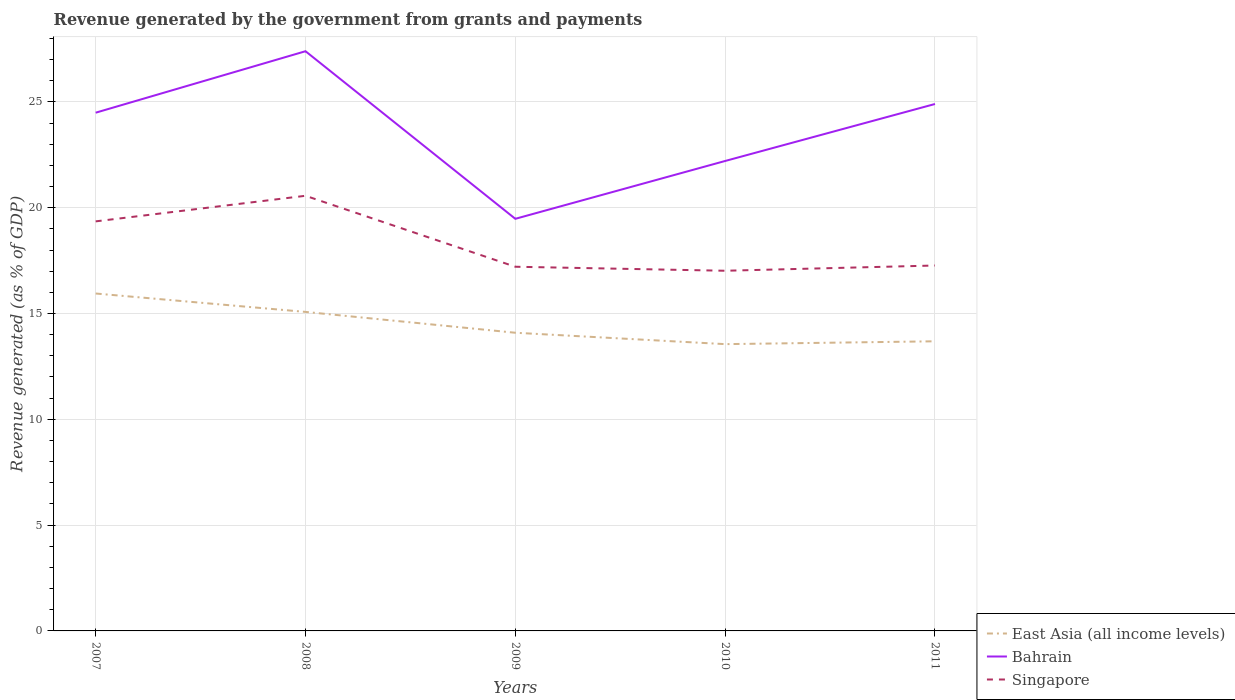Does the line corresponding to Bahrain intersect with the line corresponding to East Asia (all income levels)?
Offer a very short reply. No. Across all years, what is the maximum revenue generated by the government in East Asia (all income levels)?
Your answer should be compact. 13.55. What is the total revenue generated by the government in Bahrain in the graph?
Offer a very short reply. -2.73. What is the difference between the highest and the second highest revenue generated by the government in Bahrain?
Make the answer very short. 7.92. What is the difference between two consecutive major ticks on the Y-axis?
Make the answer very short. 5. Does the graph contain any zero values?
Give a very brief answer. No. Does the graph contain grids?
Offer a terse response. Yes. How are the legend labels stacked?
Your answer should be compact. Vertical. What is the title of the graph?
Provide a succinct answer. Revenue generated by the government from grants and payments. Does "Kosovo" appear as one of the legend labels in the graph?
Offer a very short reply. No. What is the label or title of the X-axis?
Your answer should be very brief. Years. What is the label or title of the Y-axis?
Offer a terse response. Revenue generated (as % of GDP). What is the Revenue generated (as % of GDP) in East Asia (all income levels) in 2007?
Your answer should be compact. 15.94. What is the Revenue generated (as % of GDP) in Bahrain in 2007?
Make the answer very short. 24.49. What is the Revenue generated (as % of GDP) in Singapore in 2007?
Give a very brief answer. 19.35. What is the Revenue generated (as % of GDP) of East Asia (all income levels) in 2008?
Make the answer very short. 15.07. What is the Revenue generated (as % of GDP) of Bahrain in 2008?
Ensure brevity in your answer.  27.39. What is the Revenue generated (as % of GDP) in Singapore in 2008?
Ensure brevity in your answer.  20.56. What is the Revenue generated (as % of GDP) of East Asia (all income levels) in 2009?
Give a very brief answer. 14.09. What is the Revenue generated (as % of GDP) of Bahrain in 2009?
Make the answer very short. 19.47. What is the Revenue generated (as % of GDP) in Singapore in 2009?
Your answer should be compact. 17.21. What is the Revenue generated (as % of GDP) in East Asia (all income levels) in 2010?
Provide a succinct answer. 13.55. What is the Revenue generated (as % of GDP) in Bahrain in 2010?
Your response must be concise. 22.21. What is the Revenue generated (as % of GDP) of Singapore in 2010?
Your answer should be very brief. 17.02. What is the Revenue generated (as % of GDP) of East Asia (all income levels) in 2011?
Make the answer very short. 13.69. What is the Revenue generated (as % of GDP) of Bahrain in 2011?
Provide a short and direct response. 24.9. What is the Revenue generated (as % of GDP) of Singapore in 2011?
Your response must be concise. 17.27. Across all years, what is the maximum Revenue generated (as % of GDP) of East Asia (all income levels)?
Offer a very short reply. 15.94. Across all years, what is the maximum Revenue generated (as % of GDP) of Bahrain?
Give a very brief answer. 27.39. Across all years, what is the maximum Revenue generated (as % of GDP) in Singapore?
Provide a short and direct response. 20.56. Across all years, what is the minimum Revenue generated (as % of GDP) of East Asia (all income levels)?
Ensure brevity in your answer.  13.55. Across all years, what is the minimum Revenue generated (as % of GDP) of Bahrain?
Ensure brevity in your answer.  19.47. Across all years, what is the minimum Revenue generated (as % of GDP) in Singapore?
Offer a very short reply. 17.02. What is the total Revenue generated (as % of GDP) in East Asia (all income levels) in the graph?
Ensure brevity in your answer.  72.35. What is the total Revenue generated (as % of GDP) in Bahrain in the graph?
Offer a very short reply. 118.46. What is the total Revenue generated (as % of GDP) in Singapore in the graph?
Give a very brief answer. 91.41. What is the difference between the Revenue generated (as % of GDP) of East Asia (all income levels) in 2007 and that in 2008?
Offer a very short reply. 0.87. What is the difference between the Revenue generated (as % of GDP) in Bahrain in 2007 and that in 2008?
Ensure brevity in your answer.  -2.91. What is the difference between the Revenue generated (as % of GDP) of Singapore in 2007 and that in 2008?
Provide a succinct answer. -1.21. What is the difference between the Revenue generated (as % of GDP) of East Asia (all income levels) in 2007 and that in 2009?
Offer a very short reply. 1.85. What is the difference between the Revenue generated (as % of GDP) of Bahrain in 2007 and that in 2009?
Ensure brevity in your answer.  5.01. What is the difference between the Revenue generated (as % of GDP) of Singapore in 2007 and that in 2009?
Your answer should be compact. 2.14. What is the difference between the Revenue generated (as % of GDP) of East Asia (all income levels) in 2007 and that in 2010?
Give a very brief answer. 2.39. What is the difference between the Revenue generated (as % of GDP) of Bahrain in 2007 and that in 2010?
Keep it short and to the point. 2.28. What is the difference between the Revenue generated (as % of GDP) in Singapore in 2007 and that in 2010?
Your answer should be compact. 2.33. What is the difference between the Revenue generated (as % of GDP) in East Asia (all income levels) in 2007 and that in 2011?
Keep it short and to the point. 2.26. What is the difference between the Revenue generated (as % of GDP) of Bahrain in 2007 and that in 2011?
Give a very brief answer. -0.41. What is the difference between the Revenue generated (as % of GDP) of Singapore in 2007 and that in 2011?
Make the answer very short. 2.09. What is the difference between the Revenue generated (as % of GDP) in East Asia (all income levels) in 2008 and that in 2009?
Keep it short and to the point. 0.99. What is the difference between the Revenue generated (as % of GDP) in Bahrain in 2008 and that in 2009?
Ensure brevity in your answer.  7.92. What is the difference between the Revenue generated (as % of GDP) of Singapore in 2008 and that in 2009?
Offer a very short reply. 3.35. What is the difference between the Revenue generated (as % of GDP) in East Asia (all income levels) in 2008 and that in 2010?
Make the answer very short. 1.52. What is the difference between the Revenue generated (as % of GDP) in Bahrain in 2008 and that in 2010?
Your answer should be very brief. 5.19. What is the difference between the Revenue generated (as % of GDP) in Singapore in 2008 and that in 2010?
Provide a succinct answer. 3.54. What is the difference between the Revenue generated (as % of GDP) in East Asia (all income levels) in 2008 and that in 2011?
Your response must be concise. 1.39. What is the difference between the Revenue generated (as % of GDP) of Bahrain in 2008 and that in 2011?
Provide a succinct answer. 2.49. What is the difference between the Revenue generated (as % of GDP) in Singapore in 2008 and that in 2011?
Offer a very short reply. 3.29. What is the difference between the Revenue generated (as % of GDP) of East Asia (all income levels) in 2009 and that in 2010?
Keep it short and to the point. 0.54. What is the difference between the Revenue generated (as % of GDP) in Bahrain in 2009 and that in 2010?
Keep it short and to the point. -2.73. What is the difference between the Revenue generated (as % of GDP) in Singapore in 2009 and that in 2010?
Keep it short and to the point. 0.19. What is the difference between the Revenue generated (as % of GDP) of East Asia (all income levels) in 2009 and that in 2011?
Your answer should be very brief. 0.4. What is the difference between the Revenue generated (as % of GDP) of Bahrain in 2009 and that in 2011?
Provide a short and direct response. -5.43. What is the difference between the Revenue generated (as % of GDP) in Singapore in 2009 and that in 2011?
Ensure brevity in your answer.  -0.06. What is the difference between the Revenue generated (as % of GDP) in East Asia (all income levels) in 2010 and that in 2011?
Keep it short and to the point. -0.13. What is the difference between the Revenue generated (as % of GDP) in Bahrain in 2010 and that in 2011?
Give a very brief answer. -2.69. What is the difference between the Revenue generated (as % of GDP) in Singapore in 2010 and that in 2011?
Provide a succinct answer. -0.25. What is the difference between the Revenue generated (as % of GDP) in East Asia (all income levels) in 2007 and the Revenue generated (as % of GDP) in Bahrain in 2008?
Your response must be concise. -11.45. What is the difference between the Revenue generated (as % of GDP) of East Asia (all income levels) in 2007 and the Revenue generated (as % of GDP) of Singapore in 2008?
Provide a short and direct response. -4.62. What is the difference between the Revenue generated (as % of GDP) in Bahrain in 2007 and the Revenue generated (as % of GDP) in Singapore in 2008?
Make the answer very short. 3.93. What is the difference between the Revenue generated (as % of GDP) in East Asia (all income levels) in 2007 and the Revenue generated (as % of GDP) in Bahrain in 2009?
Offer a terse response. -3.53. What is the difference between the Revenue generated (as % of GDP) in East Asia (all income levels) in 2007 and the Revenue generated (as % of GDP) in Singapore in 2009?
Your answer should be very brief. -1.27. What is the difference between the Revenue generated (as % of GDP) in Bahrain in 2007 and the Revenue generated (as % of GDP) in Singapore in 2009?
Provide a short and direct response. 7.28. What is the difference between the Revenue generated (as % of GDP) of East Asia (all income levels) in 2007 and the Revenue generated (as % of GDP) of Bahrain in 2010?
Provide a short and direct response. -6.26. What is the difference between the Revenue generated (as % of GDP) of East Asia (all income levels) in 2007 and the Revenue generated (as % of GDP) of Singapore in 2010?
Provide a succinct answer. -1.08. What is the difference between the Revenue generated (as % of GDP) in Bahrain in 2007 and the Revenue generated (as % of GDP) in Singapore in 2010?
Make the answer very short. 7.47. What is the difference between the Revenue generated (as % of GDP) in East Asia (all income levels) in 2007 and the Revenue generated (as % of GDP) in Bahrain in 2011?
Your answer should be compact. -8.96. What is the difference between the Revenue generated (as % of GDP) of East Asia (all income levels) in 2007 and the Revenue generated (as % of GDP) of Singapore in 2011?
Offer a very short reply. -1.32. What is the difference between the Revenue generated (as % of GDP) in Bahrain in 2007 and the Revenue generated (as % of GDP) in Singapore in 2011?
Give a very brief answer. 7.22. What is the difference between the Revenue generated (as % of GDP) of East Asia (all income levels) in 2008 and the Revenue generated (as % of GDP) of Bahrain in 2009?
Your answer should be compact. -4.4. What is the difference between the Revenue generated (as % of GDP) in East Asia (all income levels) in 2008 and the Revenue generated (as % of GDP) in Singapore in 2009?
Your answer should be very brief. -2.13. What is the difference between the Revenue generated (as % of GDP) in Bahrain in 2008 and the Revenue generated (as % of GDP) in Singapore in 2009?
Offer a terse response. 10.18. What is the difference between the Revenue generated (as % of GDP) of East Asia (all income levels) in 2008 and the Revenue generated (as % of GDP) of Bahrain in 2010?
Offer a very short reply. -7.13. What is the difference between the Revenue generated (as % of GDP) in East Asia (all income levels) in 2008 and the Revenue generated (as % of GDP) in Singapore in 2010?
Your response must be concise. -1.94. What is the difference between the Revenue generated (as % of GDP) in Bahrain in 2008 and the Revenue generated (as % of GDP) in Singapore in 2010?
Ensure brevity in your answer.  10.37. What is the difference between the Revenue generated (as % of GDP) of East Asia (all income levels) in 2008 and the Revenue generated (as % of GDP) of Bahrain in 2011?
Your answer should be very brief. -9.82. What is the difference between the Revenue generated (as % of GDP) in East Asia (all income levels) in 2008 and the Revenue generated (as % of GDP) in Singapore in 2011?
Offer a terse response. -2.19. What is the difference between the Revenue generated (as % of GDP) of Bahrain in 2008 and the Revenue generated (as % of GDP) of Singapore in 2011?
Keep it short and to the point. 10.13. What is the difference between the Revenue generated (as % of GDP) in East Asia (all income levels) in 2009 and the Revenue generated (as % of GDP) in Bahrain in 2010?
Ensure brevity in your answer.  -8.12. What is the difference between the Revenue generated (as % of GDP) in East Asia (all income levels) in 2009 and the Revenue generated (as % of GDP) in Singapore in 2010?
Offer a very short reply. -2.93. What is the difference between the Revenue generated (as % of GDP) in Bahrain in 2009 and the Revenue generated (as % of GDP) in Singapore in 2010?
Keep it short and to the point. 2.45. What is the difference between the Revenue generated (as % of GDP) in East Asia (all income levels) in 2009 and the Revenue generated (as % of GDP) in Bahrain in 2011?
Provide a succinct answer. -10.81. What is the difference between the Revenue generated (as % of GDP) in East Asia (all income levels) in 2009 and the Revenue generated (as % of GDP) in Singapore in 2011?
Provide a succinct answer. -3.18. What is the difference between the Revenue generated (as % of GDP) in Bahrain in 2009 and the Revenue generated (as % of GDP) in Singapore in 2011?
Your answer should be very brief. 2.21. What is the difference between the Revenue generated (as % of GDP) of East Asia (all income levels) in 2010 and the Revenue generated (as % of GDP) of Bahrain in 2011?
Provide a succinct answer. -11.35. What is the difference between the Revenue generated (as % of GDP) of East Asia (all income levels) in 2010 and the Revenue generated (as % of GDP) of Singapore in 2011?
Ensure brevity in your answer.  -3.72. What is the difference between the Revenue generated (as % of GDP) in Bahrain in 2010 and the Revenue generated (as % of GDP) in Singapore in 2011?
Provide a succinct answer. 4.94. What is the average Revenue generated (as % of GDP) in East Asia (all income levels) per year?
Provide a short and direct response. 14.47. What is the average Revenue generated (as % of GDP) in Bahrain per year?
Your answer should be compact. 23.69. What is the average Revenue generated (as % of GDP) of Singapore per year?
Your response must be concise. 18.28. In the year 2007, what is the difference between the Revenue generated (as % of GDP) in East Asia (all income levels) and Revenue generated (as % of GDP) in Bahrain?
Your response must be concise. -8.54. In the year 2007, what is the difference between the Revenue generated (as % of GDP) in East Asia (all income levels) and Revenue generated (as % of GDP) in Singapore?
Offer a terse response. -3.41. In the year 2007, what is the difference between the Revenue generated (as % of GDP) of Bahrain and Revenue generated (as % of GDP) of Singapore?
Give a very brief answer. 5.13. In the year 2008, what is the difference between the Revenue generated (as % of GDP) of East Asia (all income levels) and Revenue generated (as % of GDP) of Bahrain?
Offer a terse response. -12.32. In the year 2008, what is the difference between the Revenue generated (as % of GDP) of East Asia (all income levels) and Revenue generated (as % of GDP) of Singapore?
Provide a short and direct response. -5.49. In the year 2008, what is the difference between the Revenue generated (as % of GDP) of Bahrain and Revenue generated (as % of GDP) of Singapore?
Your answer should be compact. 6.83. In the year 2009, what is the difference between the Revenue generated (as % of GDP) in East Asia (all income levels) and Revenue generated (as % of GDP) in Bahrain?
Keep it short and to the point. -5.38. In the year 2009, what is the difference between the Revenue generated (as % of GDP) of East Asia (all income levels) and Revenue generated (as % of GDP) of Singapore?
Provide a succinct answer. -3.12. In the year 2009, what is the difference between the Revenue generated (as % of GDP) of Bahrain and Revenue generated (as % of GDP) of Singapore?
Ensure brevity in your answer.  2.26. In the year 2010, what is the difference between the Revenue generated (as % of GDP) of East Asia (all income levels) and Revenue generated (as % of GDP) of Bahrain?
Provide a succinct answer. -8.66. In the year 2010, what is the difference between the Revenue generated (as % of GDP) of East Asia (all income levels) and Revenue generated (as % of GDP) of Singapore?
Your answer should be very brief. -3.47. In the year 2010, what is the difference between the Revenue generated (as % of GDP) of Bahrain and Revenue generated (as % of GDP) of Singapore?
Your answer should be very brief. 5.19. In the year 2011, what is the difference between the Revenue generated (as % of GDP) of East Asia (all income levels) and Revenue generated (as % of GDP) of Bahrain?
Offer a terse response. -11.21. In the year 2011, what is the difference between the Revenue generated (as % of GDP) in East Asia (all income levels) and Revenue generated (as % of GDP) in Singapore?
Your response must be concise. -3.58. In the year 2011, what is the difference between the Revenue generated (as % of GDP) in Bahrain and Revenue generated (as % of GDP) in Singapore?
Make the answer very short. 7.63. What is the ratio of the Revenue generated (as % of GDP) in East Asia (all income levels) in 2007 to that in 2008?
Your answer should be very brief. 1.06. What is the ratio of the Revenue generated (as % of GDP) of Bahrain in 2007 to that in 2008?
Your answer should be compact. 0.89. What is the ratio of the Revenue generated (as % of GDP) of Singapore in 2007 to that in 2008?
Offer a very short reply. 0.94. What is the ratio of the Revenue generated (as % of GDP) of East Asia (all income levels) in 2007 to that in 2009?
Provide a succinct answer. 1.13. What is the ratio of the Revenue generated (as % of GDP) of Bahrain in 2007 to that in 2009?
Provide a short and direct response. 1.26. What is the ratio of the Revenue generated (as % of GDP) in Singapore in 2007 to that in 2009?
Provide a short and direct response. 1.12. What is the ratio of the Revenue generated (as % of GDP) of East Asia (all income levels) in 2007 to that in 2010?
Give a very brief answer. 1.18. What is the ratio of the Revenue generated (as % of GDP) in Bahrain in 2007 to that in 2010?
Make the answer very short. 1.1. What is the ratio of the Revenue generated (as % of GDP) of Singapore in 2007 to that in 2010?
Offer a terse response. 1.14. What is the ratio of the Revenue generated (as % of GDP) of East Asia (all income levels) in 2007 to that in 2011?
Keep it short and to the point. 1.17. What is the ratio of the Revenue generated (as % of GDP) in Bahrain in 2007 to that in 2011?
Provide a short and direct response. 0.98. What is the ratio of the Revenue generated (as % of GDP) of Singapore in 2007 to that in 2011?
Make the answer very short. 1.12. What is the ratio of the Revenue generated (as % of GDP) of East Asia (all income levels) in 2008 to that in 2009?
Keep it short and to the point. 1.07. What is the ratio of the Revenue generated (as % of GDP) in Bahrain in 2008 to that in 2009?
Provide a succinct answer. 1.41. What is the ratio of the Revenue generated (as % of GDP) in Singapore in 2008 to that in 2009?
Keep it short and to the point. 1.19. What is the ratio of the Revenue generated (as % of GDP) of East Asia (all income levels) in 2008 to that in 2010?
Offer a very short reply. 1.11. What is the ratio of the Revenue generated (as % of GDP) in Bahrain in 2008 to that in 2010?
Give a very brief answer. 1.23. What is the ratio of the Revenue generated (as % of GDP) in Singapore in 2008 to that in 2010?
Provide a short and direct response. 1.21. What is the ratio of the Revenue generated (as % of GDP) of East Asia (all income levels) in 2008 to that in 2011?
Your response must be concise. 1.1. What is the ratio of the Revenue generated (as % of GDP) in Bahrain in 2008 to that in 2011?
Ensure brevity in your answer.  1.1. What is the ratio of the Revenue generated (as % of GDP) in Singapore in 2008 to that in 2011?
Make the answer very short. 1.19. What is the ratio of the Revenue generated (as % of GDP) of East Asia (all income levels) in 2009 to that in 2010?
Provide a short and direct response. 1.04. What is the ratio of the Revenue generated (as % of GDP) of Bahrain in 2009 to that in 2010?
Offer a very short reply. 0.88. What is the ratio of the Revenue generated (as % of GDP) in Singapore in 2009 to that in 2010?
Your answer should be compact. 1.01. What is the ratio of the Revenue generated (as % of GDP) of East Asia (all income levels) in 2009 to that in 2011?
Offer a terse response. 1.03. What is the ratio of the Revenue generated (as % of GDP) of Bahrain in 2009 to that in 2011?
Give a very brief answer. 0.78. What is the ratio of the Revenue generated (as % of GDP) in East Asia (all income levels) in 2010 to that in 2011?
Make the answer very short. 0.99. What is the ratio of the Revenue generated (as % of GDP) of Bahrain in 2010 to that in 2011?
Your response must be concise. 0.89. What is the ratio of the Revenue generated (as % of GDP) of Singapore in 2010 to that in 2011?
Provide a short and direct response. 0.99. What is the difference between the highest and the second highest Revenue generated (as % of GDP) in East Asia (all income levels)?
Your answer should be compact. 0.87. What is the difference between the highest and the second highest Revenue generated (as % of GDP) of Bahrain?
Provide a short and direct response. 2.49. What is the difference between the highest and the second highest Revenue generated (as % of GDP) in Singapore?
Your answer should be compact. 1.21. What is the difference between the highest and the lowest Revenue generated (as % of GDP) of East Asia (all income levels)?
Provide a short and direct response. 2.39. What is the difference between the highest and the lowest Revenue generated (as % of GDP) in Bahrain?
Your answer should be compact. 7.92. What is the difference between the highest and the lowest Revenue generated (as % of GDP) in Singapore?
Provide a short and direct response. 3.54. 